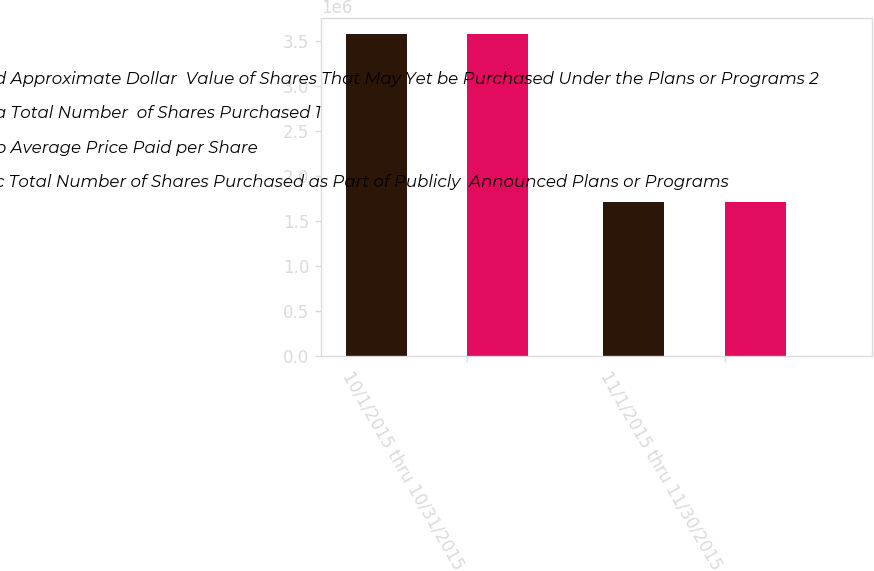Convert chart. <chart><loc_0><loc_0><loc_500><loc_500><stacked_bar_chart><ecel><fcel>10/1/2015 thru 10/31/2015<fcel>11/1/2015 thru 11/30/2015<nl><fcel>d Approximate Dollar  Value of Shares That May Yet be Purchased Under the Plans or Programs 2<fcel>3.582e+06<fcel>1.71841e+06<nl><fcel>a Total Number  of Shares Purchased 1<fcel>139.77<fcel>145.83<nl><fcel>b Average Price Paid per Share<fcel>3.57776e+06<fcel>1.7146e+06<nl><fcel>c Total Number of Shares Purchased as Part of Publicly  Announced Plans or Programs<fcel>5500<fcel>5250<nl></chart> 